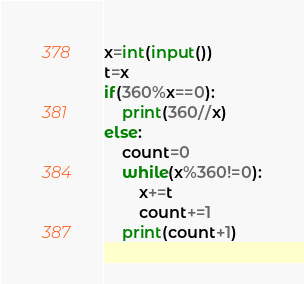Convert code to text. <code><loc_0><loc_0><loc_500><loc_500><_Python_>x=int(input())
t=x
if(360%x==0):
    print(360//x)
else:
    count=0
    while(x%360!=0):
        x+=t
        count+=1
    print(count+1)</code> 